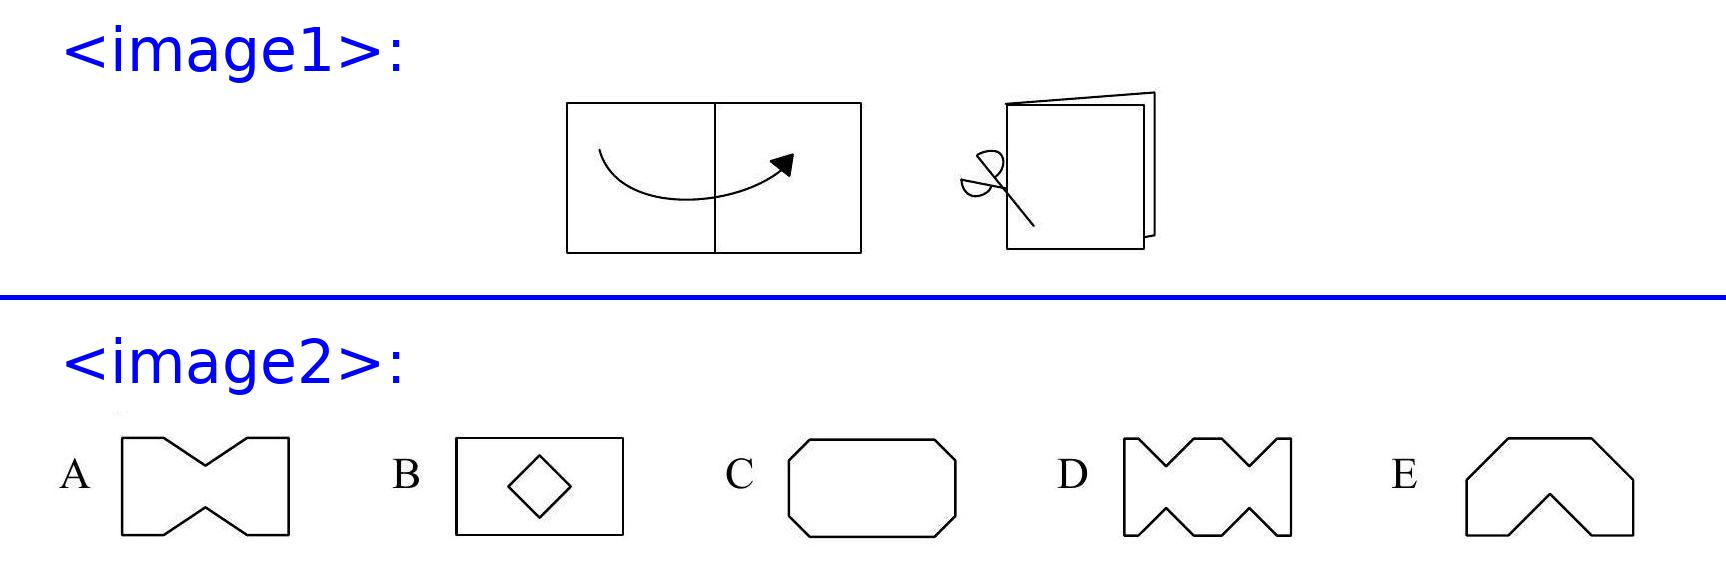<image1> How would adjusting the angle of the cuts change the resulting shapes? Adjusting the angle of the cuts can drastically change the resulting shapes. If cuts are made at an angle, they can create more dynamic and less symmetrical shapes upon unfolding. This would allow for more complex shapes than straightforward horizontal or vertical cuts. Could you describe a potential cut that would result in a shape similar to option E? To create a shape similar to option E, Werner should make one cut starting from the folded edge and angling towards the center but ending short, and then making a mirrored corresponding cut on the opposite side. This creates the peaked arches that mirror each other when unfolded, resembling option E. 